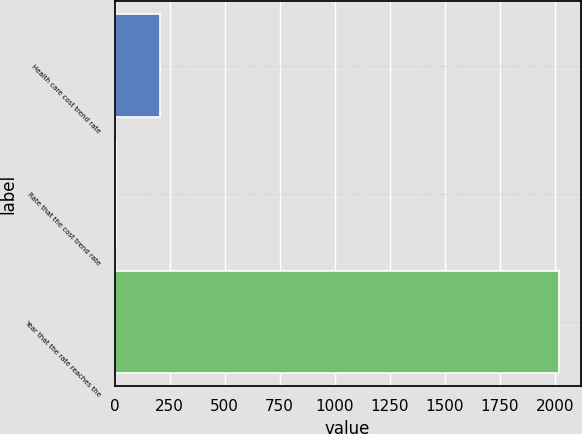Convert chart to OTSL. <chart><loc_0><loc_0><loc_500><loc_500><bar_chart><fcel>Health care cost trend rate<fcel>Rate that the cost trend rate<fcel>Year that the rate reaches the<nl><fcel>206.2<fcel>5<fcel>2017<nl></chart> 